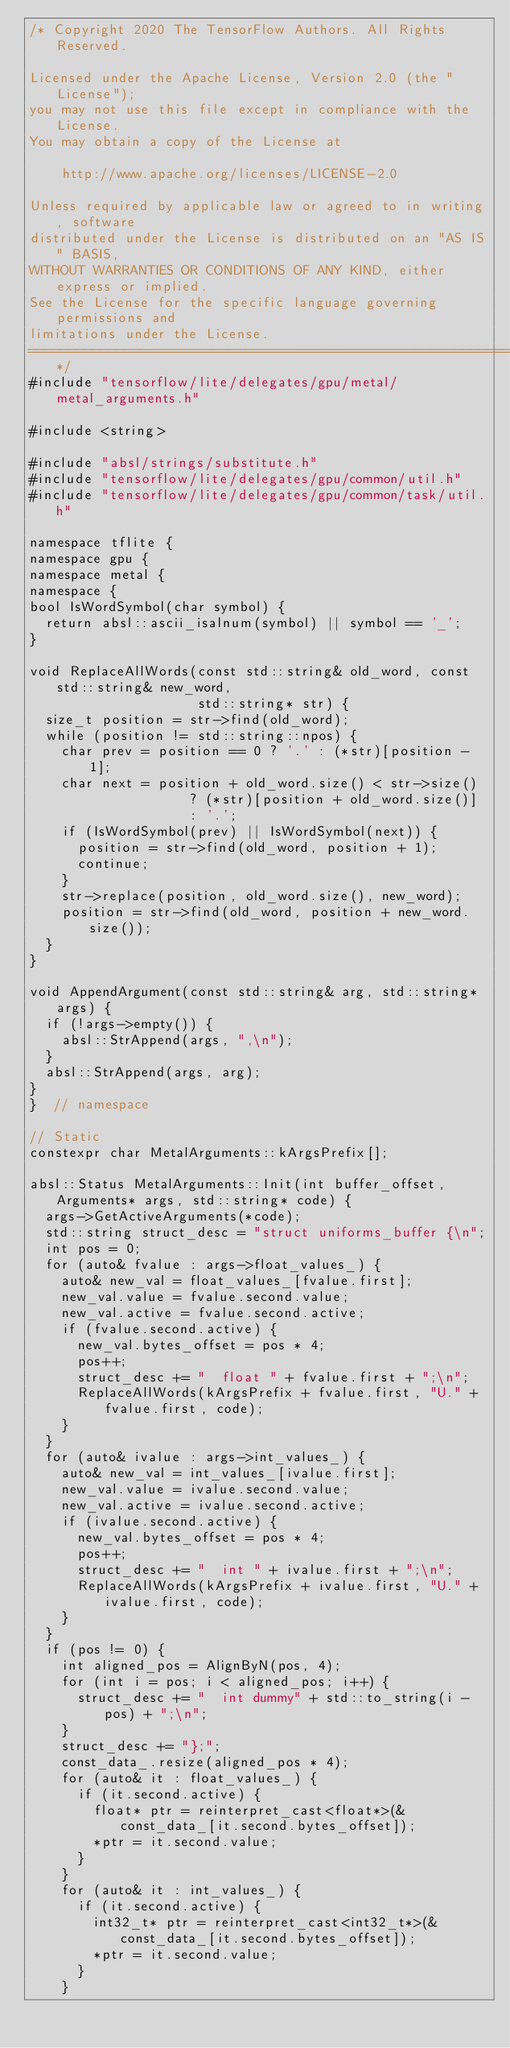Convert code to text. <code><loc_0><loc_0><loc_500><loc_500><_ObjectiveC_>/* Copyright 2020 The TensorFlow Authors. All Rights Reserved.

Licensed under the Apache License, Version 2.0 (the "License");
you may not use this file except in compliance with the License.
You may obtain a copy of the License at

    http://www.apache.org/licenses/LICENSE-2.0

Unless required by applicable law or agreed to in writing, software
distributed under the License is distributed on an "AS IS" BASIS,
WITHOUT WARRANTIES OR CONDITIONS OF ANY KIND, either express or implied.
See the License for the specific language governing permissions and
limitations under the License.
==============================================================================*/
#include "tensorflow/lite/delegates/gpu/metal/metal_arguments.h"

#include <string>

#include "absl/strings/substitute.h"
#include "tensorflow/lite/delegates/gpu/common/util.h"
#include "tensorflow/lite/delegates/gpu/common/task/util.h"

namespace tflite {
namespace gpu {
namespace metal {
namespace {
bool IsWordSymbol(char symbol) {
  return absl::ascii_isalnum(symbol) || symbol == '_';
}

void ReplaceAllWords(const std::string& old_word, const std::string& new_word,
                     std::string* str) {
  size_t position = str->find(old_word);
  while (position != std::string::npos) {
    char prev = position == 0 ? '.' : (*str)[position - 1];
    char next = position + old_word.size() < str->size()
                    ? (*str)[position + old_word.size()]
                    : '.';
    if (IsWordSymbol(prev) || IsWordSymbol(next)) {
      position = str->find(old_word, position + 1);
      continue;
    }
    str->replace(position, old_word.size(), new_word);
    position = str->find(old_word, position + new_word.size());
  }
}

void AppendArgument(const std::string& arg, std::string* args) {
  if (!args->empty()) {
    absl::StrAppend(args, ",\n");
  }
  absl::StrAppend(args, arg);
}
}  // namespace

// Static
constexpr char MetalArguments::kArgsPrefix[];

absl::Status MetalArguments::Init(int buffer_offset, Arguments* args, std::string* code) {
  args->GetActiveArguments(*code);
  std::string struct_desc = "struct uniforms_buffer {\n";
  int pos = 0;
  for (auto& fvalue : args->float_values_) {
    auto& new_val = float_values_[fvalue.first];
    new_val.value = fvalue.second.value;
    new_val.active = fvalue.second.active;
    if (fvalue.second.active) {
      new_val.bytes_offset = pos * 4;
      pos++;
      struct_desc += "  float " + fvalue.first + ";\n";
      ReplaceAllWords(kArgsPrefix + fvalue.first, "U." + fvalue.first, code);
    }
  }
  for (auto& ivalue : args->int_values_) {
    auto& new_val = int_values_[ivalue.first];
    new_val.value = ivalue.second.value;
    new_val.active = ivalue.second.active;
    if (ivalue.second.active) {
      new_val.bytes_offset = pos * 4;
      pos++;
      struct_desc += "  int " + ivalue.first + ";\n";
      ReplaceAllWords(kArgsPrefix + ivalue.first, "U." + ivalue.first, code);
    }
  }
  if (pos != 0) {
    int aligned_pos = AlignByN(pos, 4);
    for (int i = pos; i < aligned_pos; i++) {
      struct_desc += "  int dummy" + std::to_string(i - pos) + ";\n";
    }
    struct_desc += "};";
    const_data_.resize(aligned_pos * 4);
    for (auto& it : float_values_) {
      if (it.second.active) {
        float* ptr = reinterpret_cast<float*>(&const_data_[it.second.bytes_offset]);
        *ptr = it.second.value;
      }
    }
    for (auto& it : int_values_) {
      if (it.second.active) {
        int32_t* ptr = reinterpret_cast<int32_t*>(&const_data_[it.second.bytes_offset]);
        *ptr = it.second.value;
      }
    }</code> 